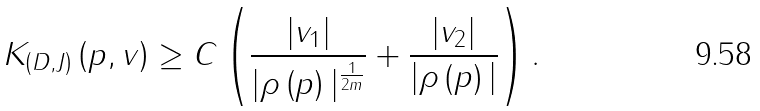Convert formula to latex. <formula><loc_0><loc_0><loc_500><loc_500>K _ { \left ( D , J \right ) } \left ( p , v \right ) \geq C \left ( \frac { | v _ { 1 } | } { | \rho \left ( p \right ) | ^ { \frac { 1 } { 2 m } } } + \frac { | v _ { 2 } | } { | \rho \left ( p \right ) | } \right ) .</formula> 